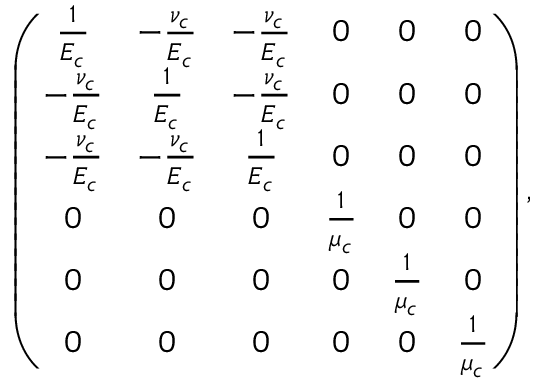<formula> <loc_0><loc_0><loc_500><loc_500>\left ( \begin{array} { c c c c c c } { \frac { 1 } { E _ { c } } } & { - \frac { \nu _ { c } } { E _ { c } } } & { - \frac { \nu _ { c } } { E _ { c } } } & { 0 } & { 0 } & { 0 } \\ { - \frac { \nu _ { c } } { E _ { c } } } & { \frac { 1 } { E _ { c } } } & { - \frac { \nu _ { c } } { E _ { c } } } & { 0 } & { 0 } & { 0 } \\ { - \frac { \nu _ { c } } { E _ { c } } } & { - \frac { \nu _ { c } } { E _ { c } } } & { \frac { 1 } { E _ { c } } } & { 0 } & { 0 } & { 0 } \\ { 0 } & { 0 } & { 0 } & { \frac { 1 } { \mu _ { c } } } & { 0 } & { 0 } \\ { 0 } & { 0 } & { 0 } & { 0 } & { \frac { 1 } { \mu _ { c } } } & { 0 } \\ { 0 } & { 0 } & { 0 } & { 0 } & { 0 } & { \frac { 1 } { \mu _ { c } } } \end{array} \right ) ,</formula> 